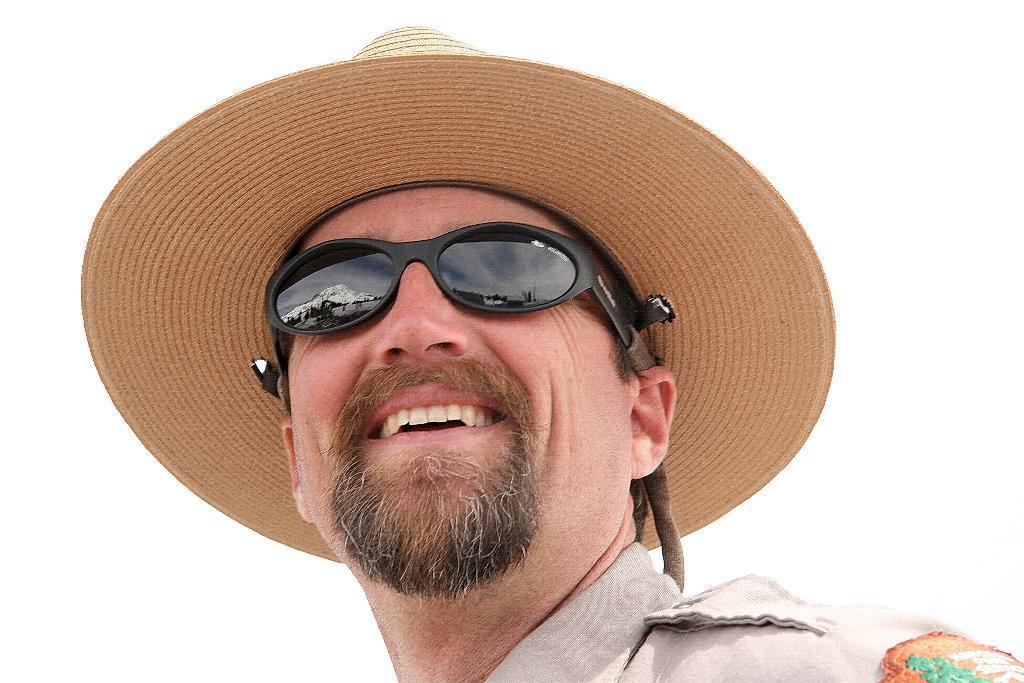Describe this image in one or two sentences. In this picture I can see a man with a smile on his face and he wore a cap and sunglasses and I can see white color background. 